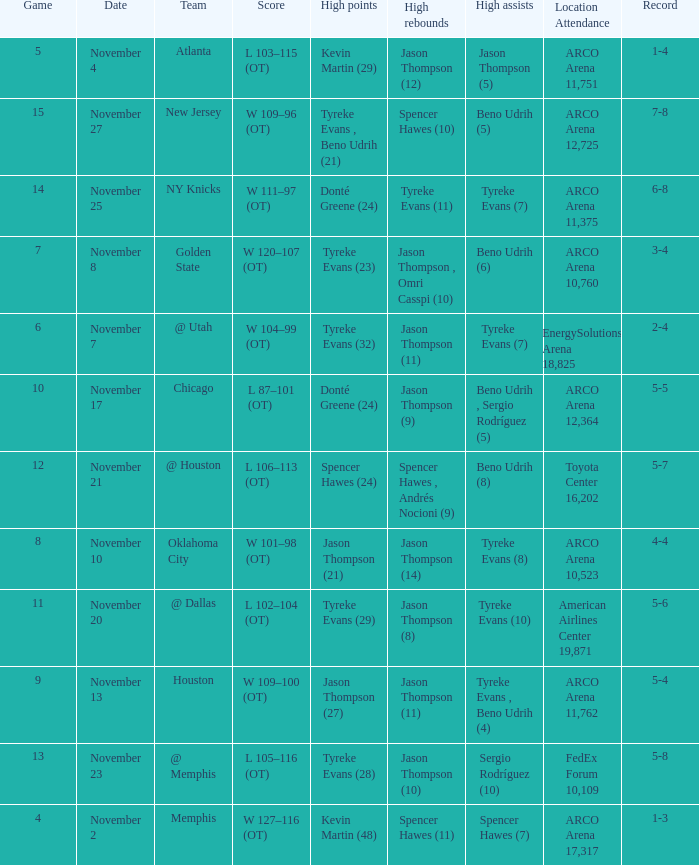If the record is 5-5, what is the game maximum? 10.0. 